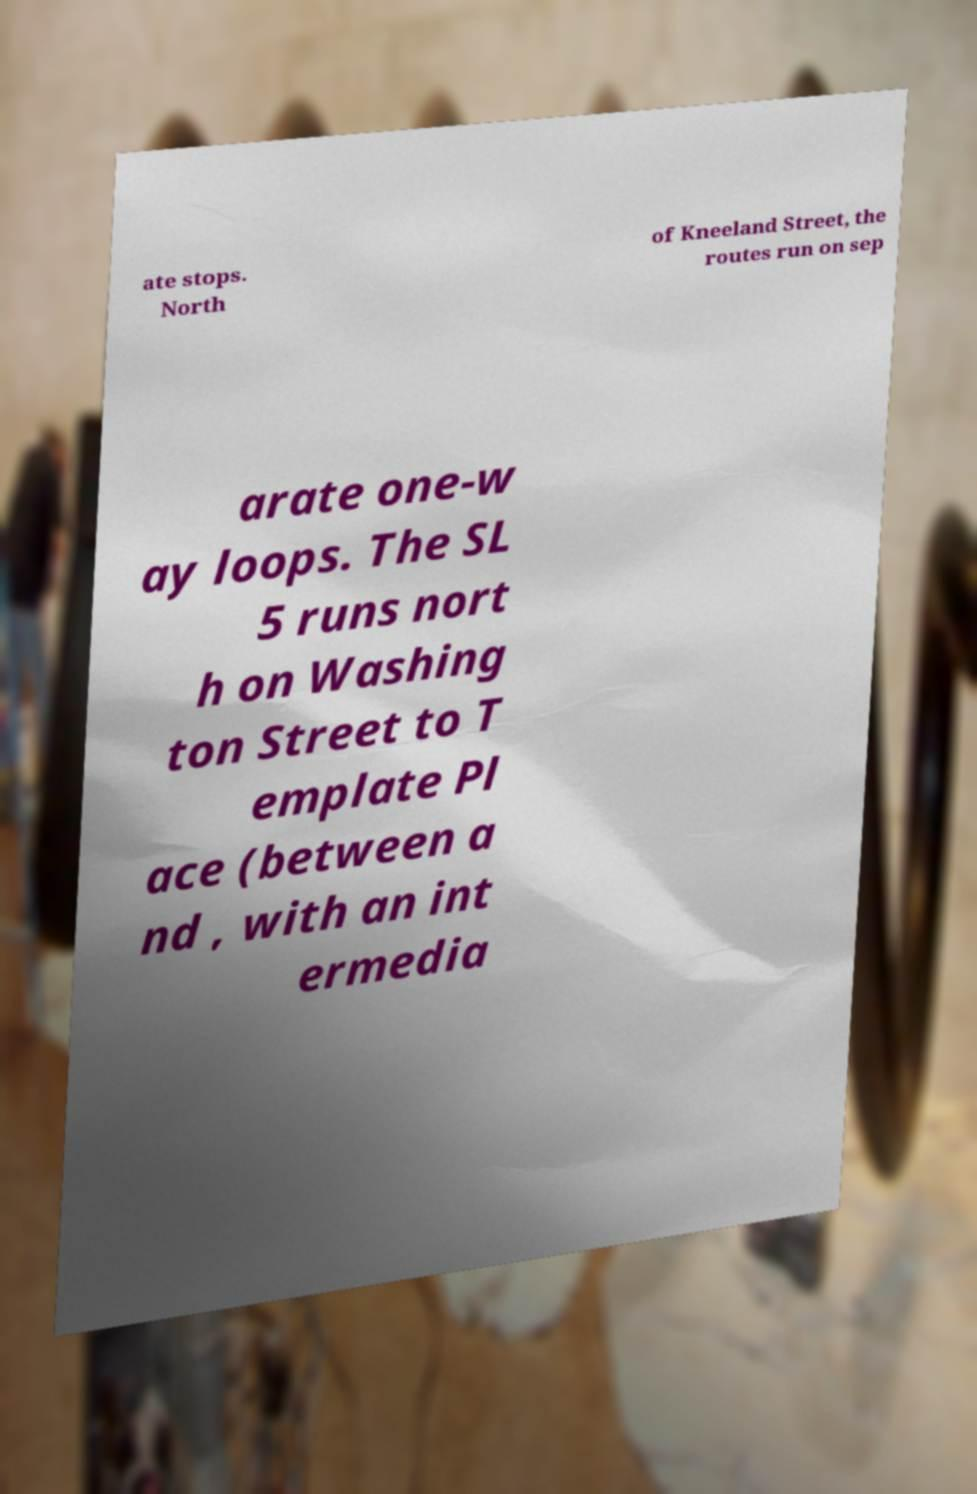Can you read and provide the text displayed in the image?This photo seems to have some interesting text. Can you extract and type it out for me? ate stops. North of Kneeland Street, the routes run on sep arate one-w ay loops. The SL 5 runs nort h on Washing ton Street to T emplate Pl ace (between a nd , with an int ermedia 